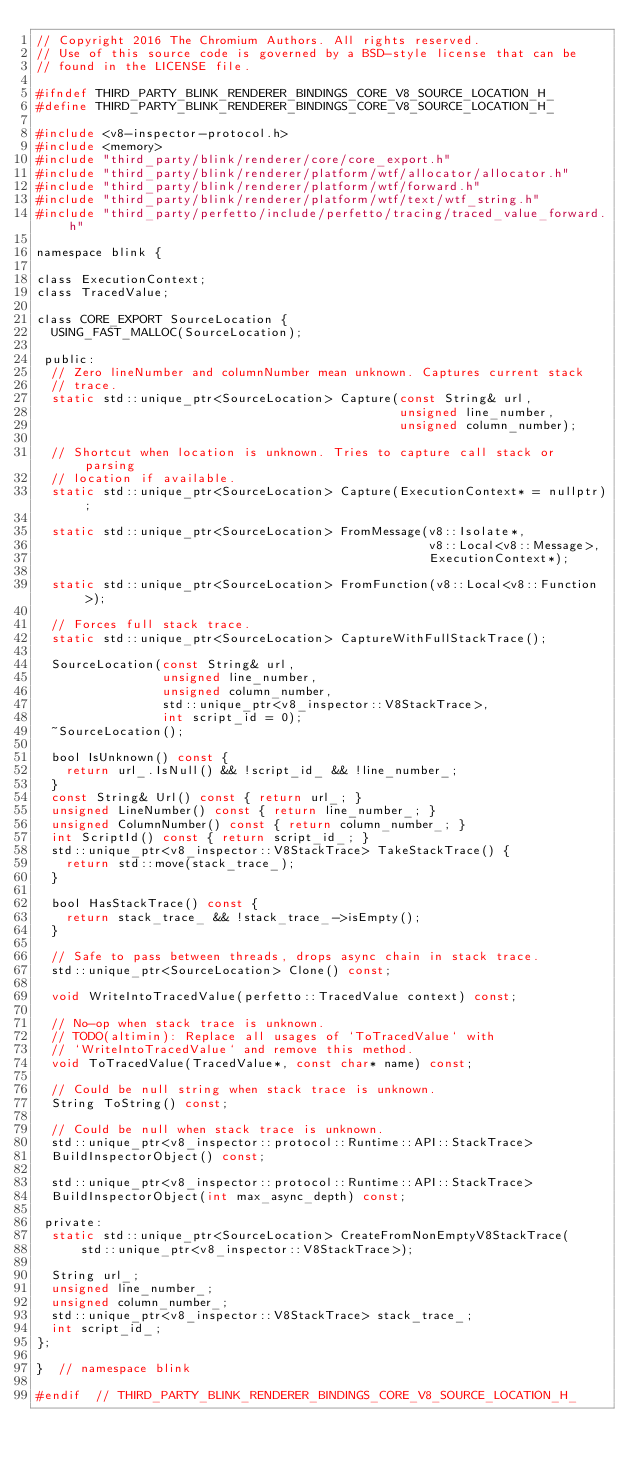<code> <loc_0><loc_0><loc_500><loc_500><_C_>// Copyright 2016 The Chromium Authors. All rights reserved.
// Use of this source code is governed by a BSD-style license that can be
// found in the LICENSE file.

#ifndef THIRD_PARTY_BLINK_RENDERER_BINDINGS_CORE_V8_SOURCE_LOCATION_H_
#define THIRD_PARTY_BLINK_RENDERER_BINDINGS_CORE_V8_SOURCE_LOCATION_H_

#include <v8-inspector-protocol.h>
#include <memory>
#include "third_party/blink/renderer/core/core_export.h"
#include "third_party/blink/renderer/platform/wtf/allocator/allocator.h"
#include "third_party/blink/renderer/platform/wtf/forward.h"
#include "third_party/blink/renderer/platform/wtf/text/wtf_string.h"
#include "third_party/perfetto/include/perfetto/tracing/traced_value_forward.h"

namespace blink {

class ExecutionContext;
class TracedValue;

class CORE_EXPORT SourceLocation {
  USING_FAST_MALLOC(SourceLocation);

 public:
  // Zero lineNumber and columnNumber mean unknown. Captures current stack
  // trace.
  static std::unique_ptr<SourceLocation> Capture(const String& url,
                                                 unsigned line_number,
                                                 unsigned column_number);

  // Shortcut when location is unknown. Tries to capture call stack or parsing
  // location if available.
  static std::unique_ptr<SourceLocation> Capture(ExecutionContext* = nullptr);

  static std::unique_ptr<SourceLocation> FromMessage(v8::Isolate*,
                                                     v8::Local<v8::Message>,
                                                     ExecutionContext*);

  static std::unique_ptr<SourceLocation> FromFunction(v8::Local<v8::Function>);

  // Forces full stack trace.
  static std::unique_ptr<SourceLocation> CaptureWithFullStackTrace();

  SourceLocation(const String& url,
                 unsigned line_number,
                 unsigned column_number,
                 std::unique_ptr<v8_inspector::V8StackTrace>,
                 int script_id = 0);
  ~SourceLocation();

  bool IsUnknown() const {
    return url_.IsNull() && !script_id_ && !line_number_;
  }
  const String& Url() const { return url_; }
  unsigned LineNumber() const { return line_number_; }
  unsigned ColumnNumber() const { return column_number_; }
  int ScriptId() const { return script_id_; }
  std::unique_ptr<v8_inspector::V8StackTrace> TakeStackTrace() {
    return std::move(stack_trace_);
  }

  bool HasStackTrace() const {
    return stack_trace_ && !stack_trace_->isEmpty();
  }

  // Safe to pass between threads, drops async chain in stack trace.
  std::unique_ptr<SourceLocation> Clone() const;

  void WriteIntoTracedValue(perfetto::TracedValue context) const;

  // No-op when stack trace is unknown.
  // TODO(altimin): Replace all usages of `ToTracedValue` with
  // `WriteIntoTracedValue` and remove this method.
  void ToTracedValue(TracedValue*, const char* name) const;

  // Could be null string when stack trace is unknown.
  String ToString() const;

  // Could be null when stack trace is unknown.
  std::unique_ptr<v8_inspector::protocol::Runtime::API::StackTrace>
  BuildInspectorObject() const;

  std::unique_ptr<v8_inspector::protocol::Runtime::API::StackTrace>
  BuildInspectorObject(int max_async_depth) const;

 private:
  static std::unique_ptr<SourceLocation> CreateFromNonEmptyV8StackTrace(
      std::unique_ptr<v8_inspector::V8StackTrace>);

  String url_;
  unsigned line_number_;
  unsigned column_number_;
  std::unique_ptr<v8_inspector::V8StackTrace> stack_trace_;
  int script_id_;
};

}  // namespace blink

#endif  // THIRD_PARTY_BLINK_RENDERER_BINDINGS_CORE_V8_SOURCE_LOCATION_H_
</code> 